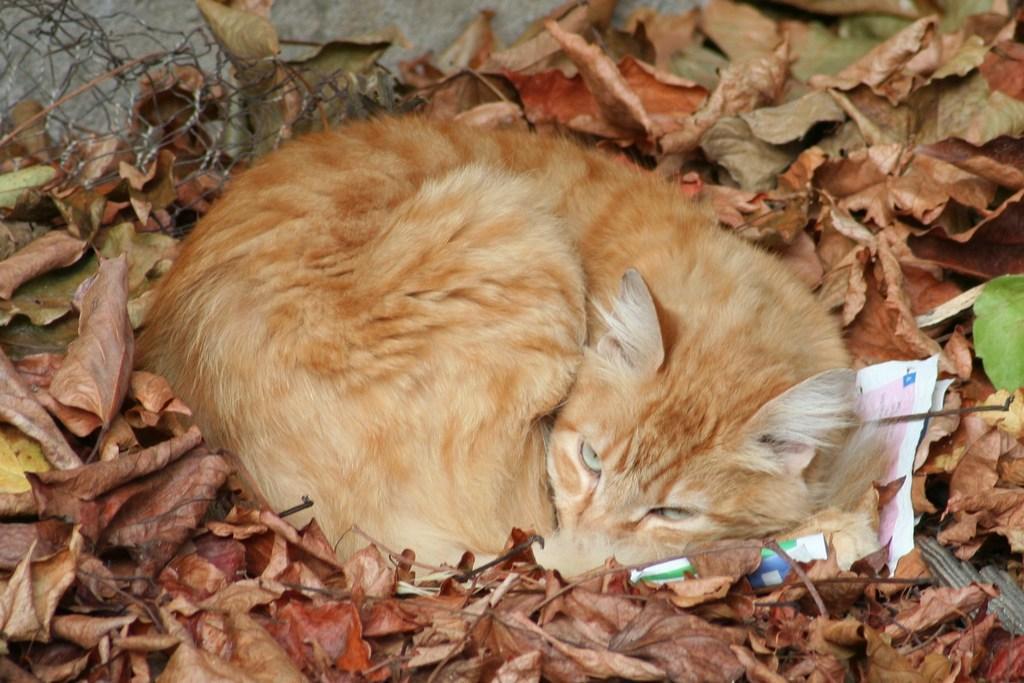Can you describe this image briefly? There is a cat sleeping and there are leaves around it and there is a fence behind it. 